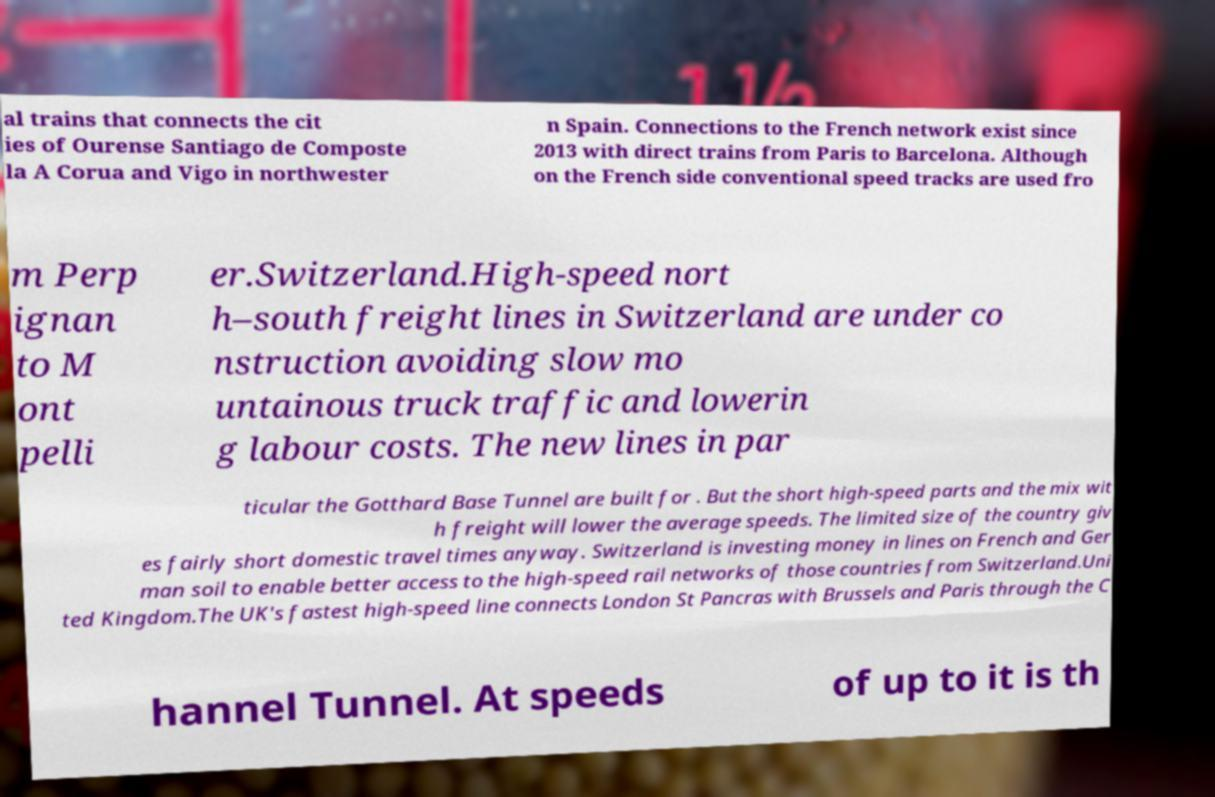Please identify and transcribe the text found in this image. al trains that connects the cit ies of Ourense Santiago de Composte la A Corua and Vigo in northwester n Spain. Connections to the French network exist since 2013 with direct trains from Paris to Barcelona. Although on the French side conventional speed tracks are used fro m Perp ignan to M ont pelli er.Switzerland.High-speed nort h–south freight lines in Switzerland are under co nstruction avoiding slow mo untainous truck traffic and lowerin g labour costs. The new lines in par ticular the Gotthard Base Tunnel are built for . But the short high-speed parts and the mix wit h freight will lower the average speeds. The limited size of the country giv es fairly short domestic travel times anyway. Switzerland is investing money in lines on French and Ger man soil to enable better access to the high-speed rail networks of those countries from Switzerland.Uni ted Kingdom.The UK's fastest high-speed line connects London St Pancras with Brussels and Paris through the C hannel Tunnel. At speeds of up to it is th 